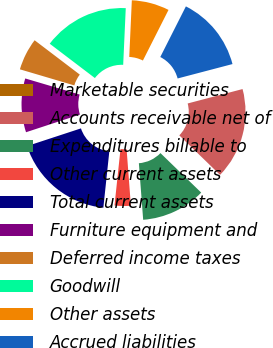Convert chart to OTSL. <chart><loc_0><loc_0><loc_500><loc_500><pie_chart><fcel>Marketable securities<fcel>Accounts receivable net of<fcel>Expenditures billable to<fcel>Other current assets<fcel>Total current assets<fcel>Furniture equipment and<fcel>Deferred income taxes<fcel>Goodwill<fcel>Other assets<fcel>Accrued liabilities<nl><fcel>0.0%<fcel>16.34%<fcel>11.54%<fcel>2.89%<fcel>18.27%<fcel>9.62%<fcel>5.77%<fcel>15.38%<fcel>6.73%<fcel>13.46%<nl></chart> 